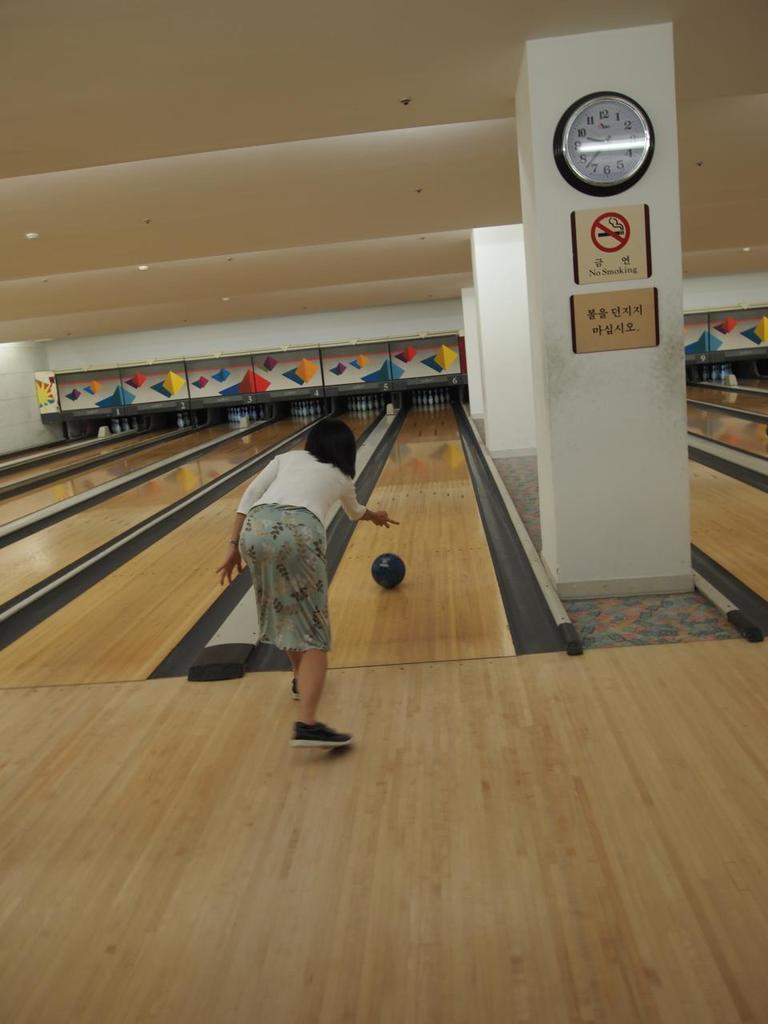What activity is the person in the image engaged in? The person is playing bowling in the image. What architectural features can be seen in the image? There are pillars in the image, including one with a clock. Are there any informational or directional signs in the image? Yes, there are sign boards in the image. What type of fog can be seen surrounding the bowling lane in the image? There is no fog present in the image; it is an indoor bowling alley. 